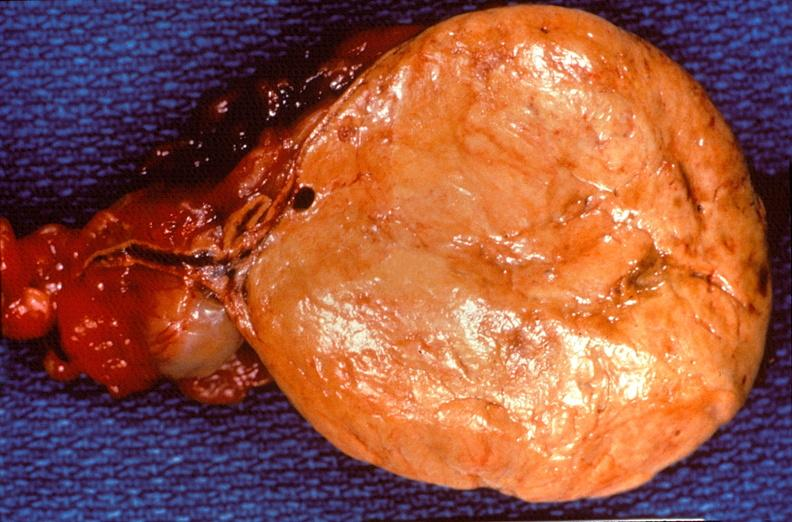does this image show pituitary, chromaphobe adenoma?
Answer the question using a single word or phrase. Yes 